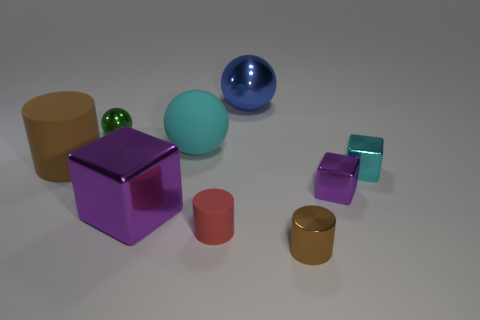Can you describe the sizes of the objects compared to each other? Certainly! The objects vary in size: the largest appears to be the blue sphere, followed by the purple cube. The small green sphere is the smallest object, with the other cylinders and cubes being of medium size, nested between the largest and smallest. 